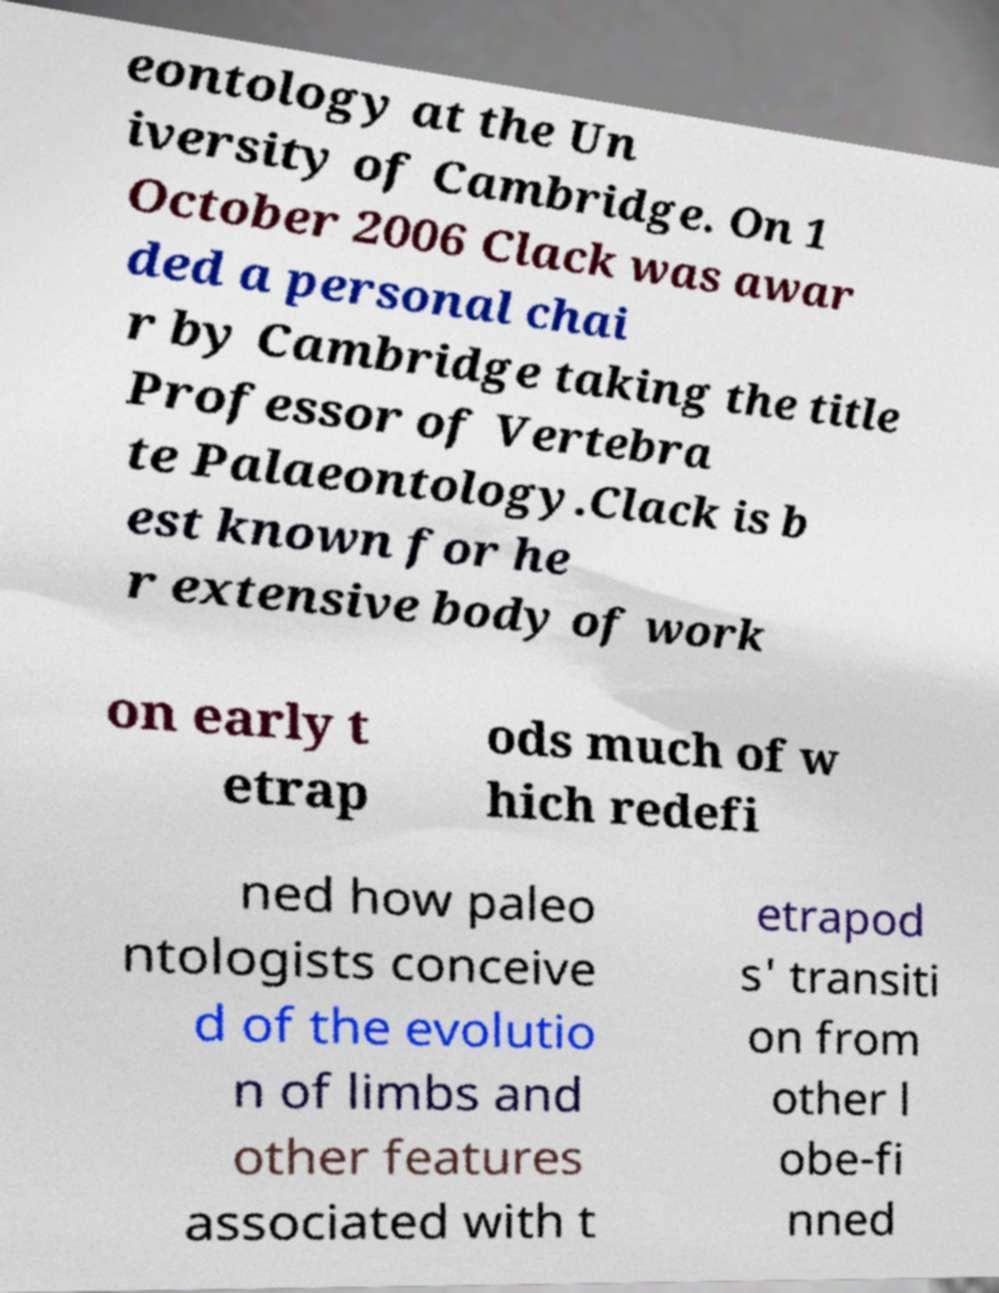What messages or text are displayed in this image? I need them in a readable, typed format. eontology at the Un iversity of Cambridge. On 1 October 2006 Clack was awar ded a personal chai r by Cambridge taking the title Professor of Vertebra te Palaeontology.Clack is b est known for he r extensive body of work on early t etrap ods much of w hich redefi ned how paleo ntologists conceive d of the evolutio n of limbs and other features associated with t etrapod s' transiti on from other l obe-fi nned 